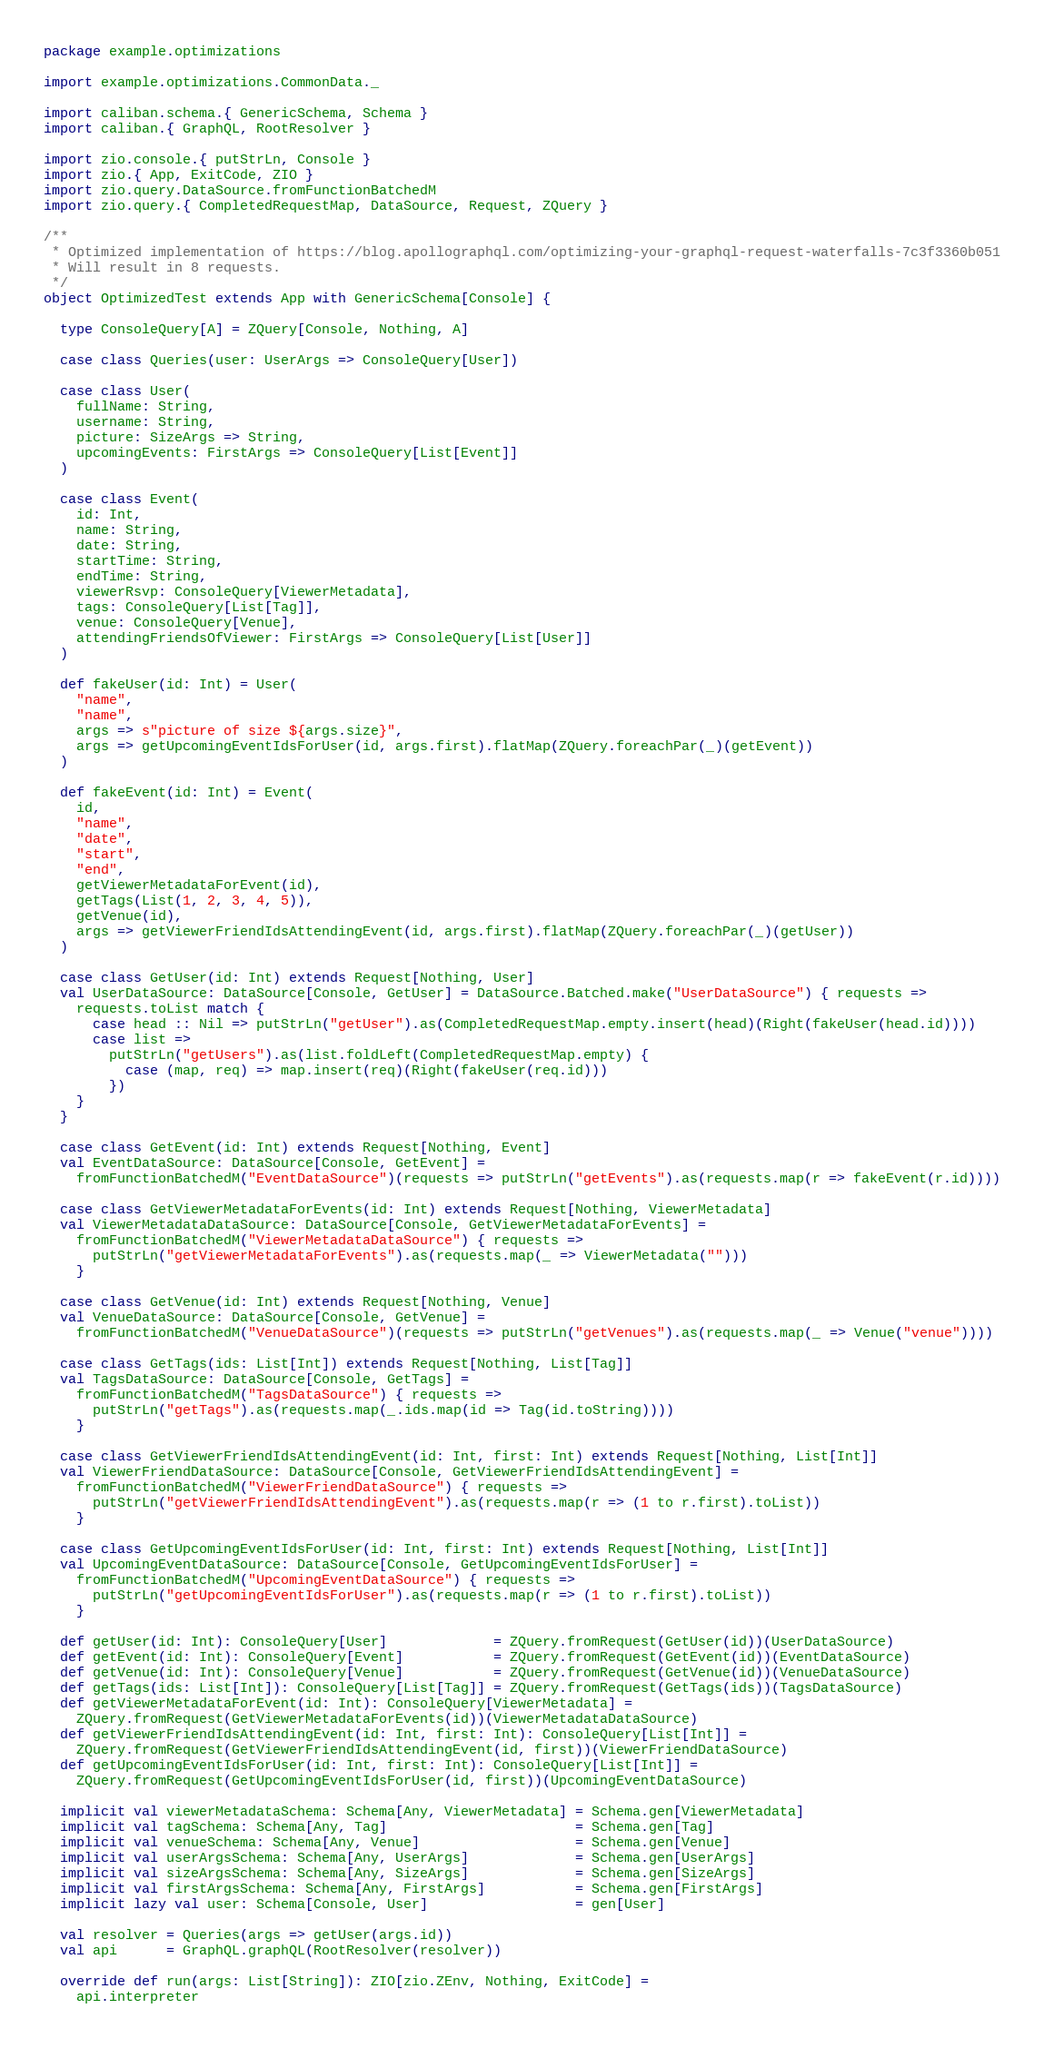<code> <loc_0><loc_0><loc_500><loc_500><_Scala_>package example.optimizations

import example.optimizations.CommonData._

import caliban.schema.{ GenericSchema, Schema }
import caliban.{ GraphQL, RootResolver }

import zio.console.{ putStrLn, Console }
import zio.{ App, ExitCode, ZIO }
import zio.query.DataSource.fromFunctionBatchedM
import zio.query.{ CompletedRequestMap, DataSource, Request, ZQuery }

/**
 * Optimized implementation of https://blog.apollographql.com/optimizing-your-graphql-request-waterfalls-7c3f3360b051
 * Will result in 8 requests.
 */
object OptimizedTest extends App with GenericSchema[Console] {

  type ConsoleQuery[A] = ZQuery[Console, Nothing, A]

  case class Queries(user: UserArgs => ConsoleQuery[User])

  case class User(
    fullName: String,
    username: String,
    picture: SizeArgs => String,
    upcomingEvents: FirstArgs => ConsoleQuery[List[Event]]
  )

  case class Event(
    id: Int,
    name: String,
    date: String,
    startTime: String,
    endTime: String,
    viewerRsvp: ConsoleQuery[ViewerMetadata],
    tags: ConsoleQuery[List[Tag]],
    venue: ConsoleQuery[Venue],
    attendingFriendsOfViewer: FirstArgs => ConsoleQuery[List[User]]
  )

  def fakeUser(id: Int) = User(
    "name",
    "name",
    args => s"picture of size ${args.size}",
    args => getUpcomingEventIdsForUser(id, args.first).flatMap(ZQuery.foreachPar(_)(getEvent))
  )

  def fakeEvent(id: Int) = Event(
    id,
    "name",
    "date",
    "start",
    "end",
    getViewerMetadataForEvent(id),
    getTags(List(1, 2, 3, 4, 5)),
    getVenue(id),
    args => getViewerFriendIdsAttendingEvent(id, args.first).flatMap(ZQuery.foreachPar(_)(getUser))
  )

  case class GetUser(id: Int) extends Request[Nothing, User]
  val UserDataSource: DataSource[Console, GetUser] = DataSource.Batched.make("UserDataSource") { requests =>
    requests.toList match {
      case head :: Nil => putStrLn("getUser").as(CompletedRequestMap.empty.insert(head)(Right(fakeUser(head.id))))
      case list =>
        putStrLn("getUsers").as(list.foldLeft(CompletedRequestMap.empty) {
          case (map, req) => map.insert(req)(Right(fakeUser(req.id)))
        })
    }
  }

  case class GetEvent(id: Int) extends Request[Nothing, Event]
  val EventDataSource: DataSource[Console, GetEvent] =
    fromFunctionBatchedM("EventDataSource")(requests => putStrLn("getEvents").as(requests.map(r => fakeEvent(r.id))))

  case class GetViewerMetadataForEvents(id: Int) extends Request[Nothing, ViewerMetadata]
  val ViewerMetadataDataSource: DataSource[Console, GetViewerMetadataForEvents] =
    fromFunctionBatchedM("ViewerMetadataDataSource") { requests =>
      putStrLn("getViewerMetadataForEvents").as(requests.map(_ => ViewerMetadata("")))
    }

  case class GetVenue(id: Int) extends Request[Nothing, Venue]
  val VenueDataSource: DataSource[Console, GetVenue] =
    fromFunctionBatchedM("VenueDataSource")(requests => putStrLn("getVenues").as(requests.map(_ => Venue("venue"))))

  case class GetTags(ids: List[Int]) extends Request[Nothing, List[Tag]]
  val TagsDataSource: DataSource[Console, GetTags] =
    fromFunctionBatchedM("TagsDataSource") { requests =>
      putStrLn("getTags").as(requests.map(_.ids.map(id => Tag(id.toString))))
    }

  case class GetViewerFriendIdsAttendingEvent(id: Int, first: Int) extends Request[Nothing, List[Int]]
  val ViewerFriendDataSource: DataSource[Console, GetViewerFriendIdsAttendingEvent] =
    fromFunctionBatchedM("ViewerFriendDataSource") { requests =>
      putStrLn("getViewerFriendIdsAttendingEvent").as(requests.map(r => (1 to r.first).toList))
    }

  case class GetUpcomingEventIdsForUser(id: Int, first: Int) extends Request[Nothing, List[Int]]
  val UpcomingEventDataSource: DataSource[Console, GetUpcomingEventIdsForUser] =
    fromFunctionBatchedM("UpcomingEventDataSource") { requests =>
      putStrLn("getUpcomingEventIdsForUser").as(requests.map(r => (1 to r.first).toList))
    }

  def getUser(id: Int): ConsoleQuery[User]             = ZQuery.fromRequest(GetUser(id))(UserDataSource)
  def getEvent(id: Int): ConsoleQuery[Event]           = ZQuery.fromRequest(GetEvent(id))(EventDataSource)
  def getVenue(id: Int): ConsoleQuery[Venue]           = ZQuery.fromRequest(GetVenue(id))(VenueDataSource)
  def getTags(ids: List[Int]): ConsoleQuery[List[Tag]] = ZQuery.fromRequest(GetTags(ids))(TagsDataSource)
  def getViewerMetadataForEvent(id: Int): ConsoleQuery[ViewerMetadata] =
    ZQuery.fromRequest(GetViewerMetadataForEvents(id))(ViewerMetadataDataSource)
  def getViewerFriendIdsAttendingEvent(id: Int, first: Int): ConsoleQuery[List[Int]] =
    ZQuery.fromRequest(GetViewerFriendIdsAttendingEvent(id, first))(ViewerFriendDataSource)
  def getUpcomingEventIdsForUser(id: Int, first: Int): ConsoleQuery[List[Int]] =
    ZQuery.fromRequest(GetUpcomingEventIdsForUser(id, first))(UpcomingEventDataSource)

  implicit val viewerMetadataSchema: Schema[Any, ViewerMetadata] = Schema.gen[ViewerMetadata]
  implicit val tagSchema: Schema[Any, Tag]                       = Schema.gen[Tag]
  implicit val venueSchema: Schema[Any, Venue]                   = Schema.gen[Venue]
  implicit val userArgsSchema: Schema[Any, UserArgs]             = Schema.gen[UserArgs]
  implicit val sizeArgsSchema: Schema[Any, SizeArgs]             = Schema.gen[SizeArgs]
  implicit val firstArgsSchema: Schema[Any, FirstArgs]           = Schema.gen[FirstArgs]
  implicit lazy val user: Schema[Console, User]                  = gen[User]

  val resolver = Queries(args => getUser(args.id))
  val api      = GraphQL.graphQL(RootResolver(resolver))

  override def run(args: List[String]): ZIO[zio.ZEnv, Nothing, ExitCode] =
    api.interpreter</code> 